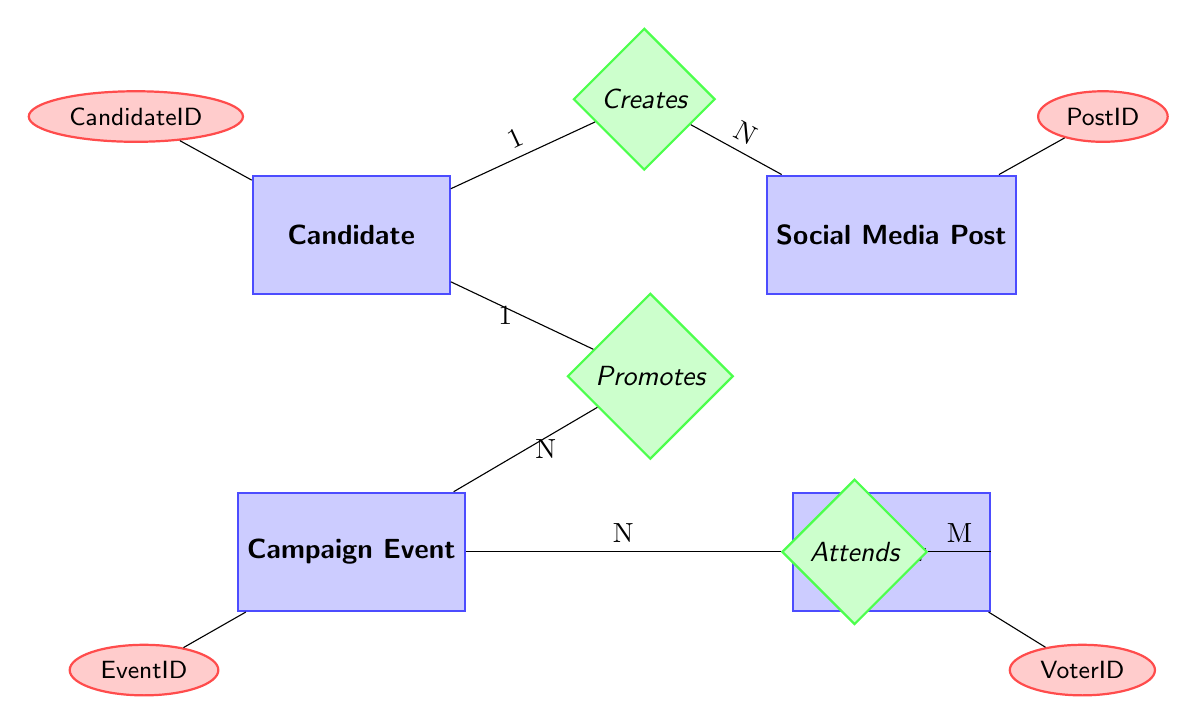What entities are present in the diagram? The diagram contains four entities: Candidate, Social Media Post, Campaign Event, and Voter.
Answer: Candidate, Social Media Post, Campaign Event, Voter How many relationships are there in the diagram? There are three relationships represented in the diagram: Creates, Attends, and Promotes.
Answer: 3 What is the cardinality between Candidate and Social Media Post? The diagram specifies a 1-to-many relationship from Candidate to Social Media Post, meaning one candidate can create multiple social media posts.
Answer: 1-to-many Which entity can attend multiple campaign events? The Voter entity has a many-to-many relationship with Campaign Event, indicating that multiple voters can attend multiple campaign events.
Answer: Voter How is the Candidate related to Campaign Events? The Candidate has a 1-to-many relationship with Campaign Event, meaning one candidate can promote multiple campaign events.
Answer: 1-to-many If a Candidate creates five Social Media Posts, how many Candidate entities are involved? There is one Candidate entity that can create those five posts, as indicated by the 1-to-many relationship from Candidate to Social Media Post.
Answer: 1 What does the relationship labeled "Attends" signify? The "Attends" relationship indicates that voters can attend multiple campaign events, and multiple voters can attend the same event, reflecting a many-to-many relationship.
Answer: Many-to-many How many Marketing Actions can one Candidate promote? One Candidate can promote multiple Campaign Events due to the 1-to-many relationship established in the diagram, indicating no fixed limit to the number of events.
Answer: Many 